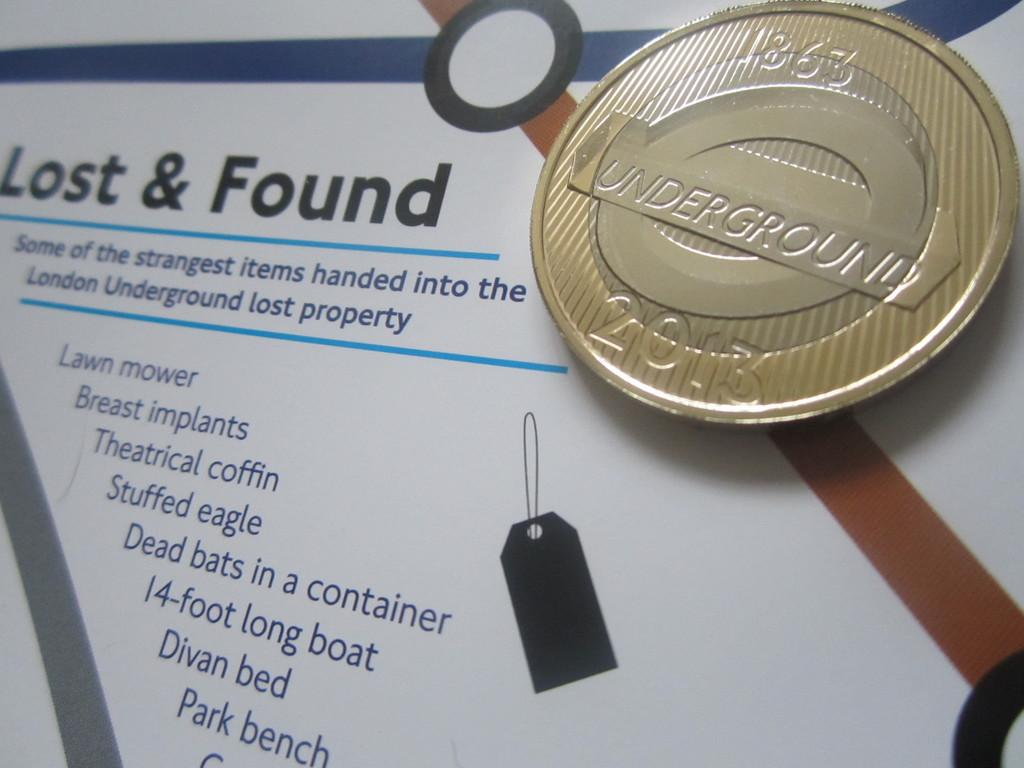What is the coin placed on in the image? The coin is placed on an object in the image. What can be found on the object besides the coin? There are texts written on the object. How many girls are playing the horn in the image? There are no girls or horns present in the image. 